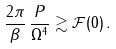Convert formula to latex. <formula><loc_0><loc_0><loc_500><loc_500>\frac { 2 \pi } { \beta } \, \frac { P } { \Omega ^ { 4 } } \gtrsim \mathcal { F } ( 0 ) \, .</formula> 